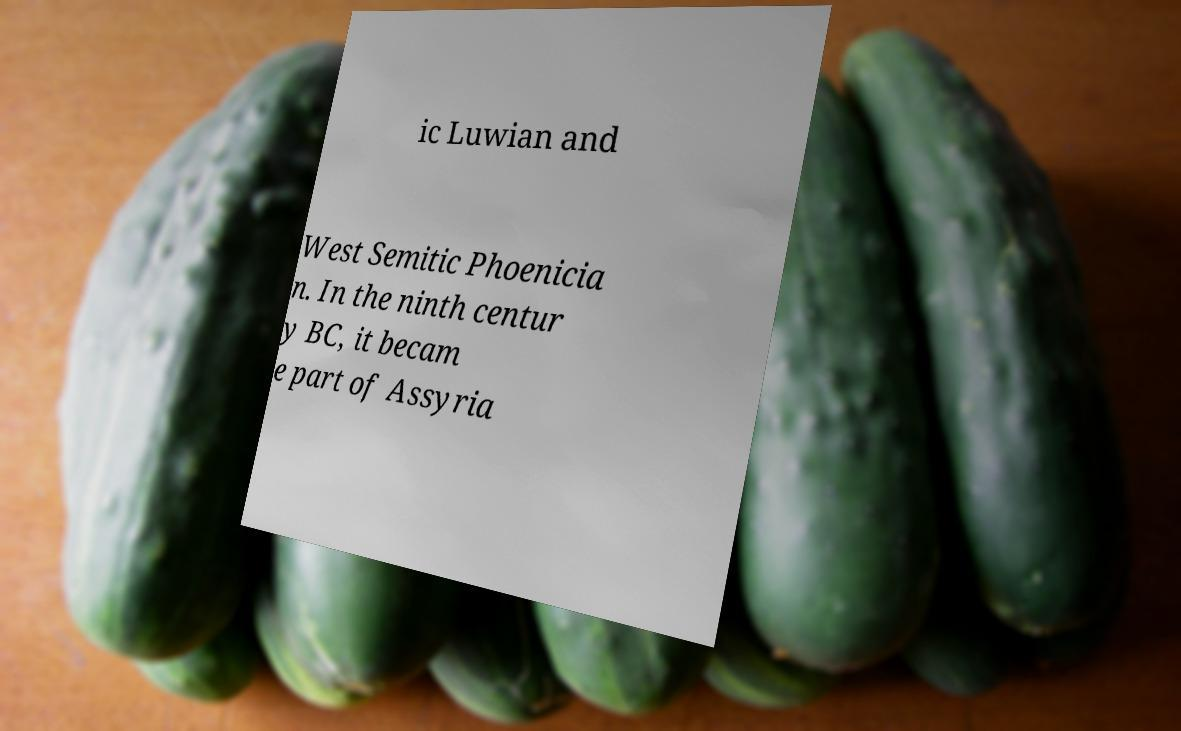Please identify and transcribe the text found in this image. ic Luwian and West Semitic Phoenicia n. In the ninth centur y BC, it becam e part of Assyria 